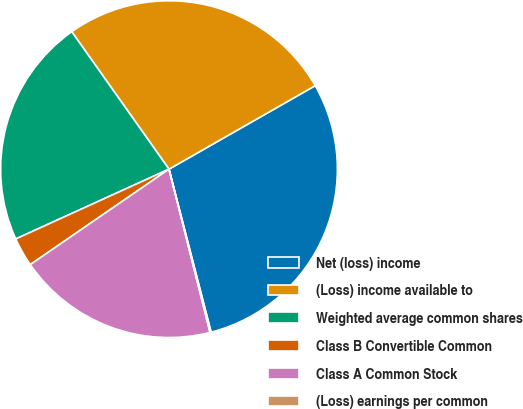Convert chart to OTSL. <chart><loc_0><loc_0><loc_500><loc_500><pie_chart><fcel>Net (loss) income<fcel>(Loss) income available to<fcel>Weighted average common shares<fcel>Class B Convertible Common<fcel>Class A Common Stock<fcel>(Loss) earnings per common<nl><fcel>29.23%<fcel>26.54%<fcel>22.0%<fcel>2.79%<fcel>19.32%<fcel>0.11%<nl></chart> 